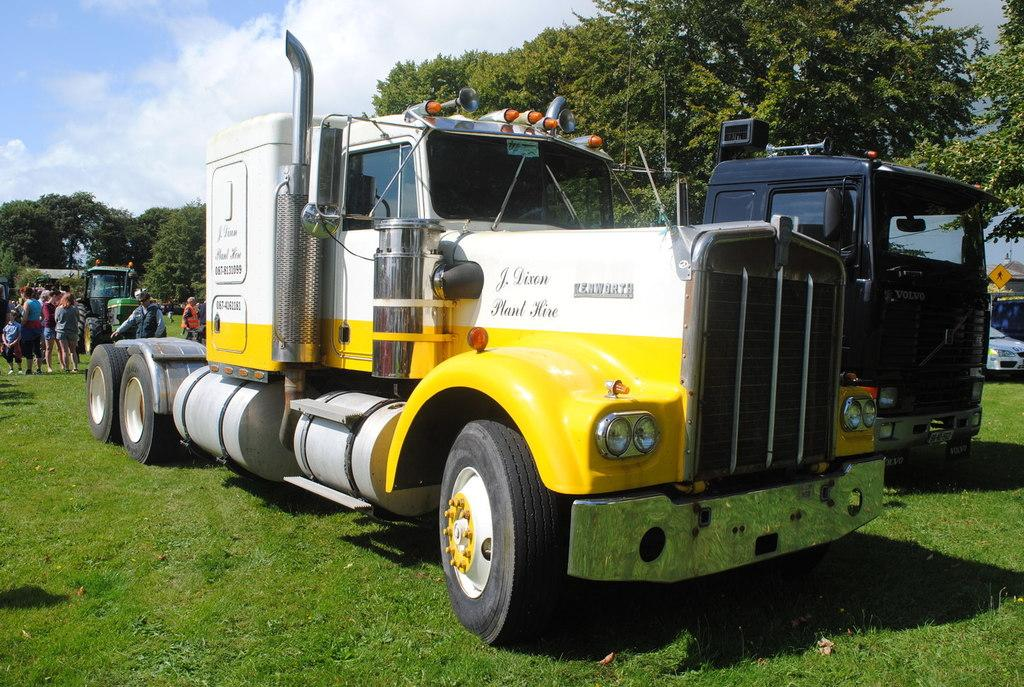What type of vehicles are on the grass in the image? There are trucks on the grass in the image. What can be seen behind the trucks? There are people standing behind the trucks. What is visible in the background of the image? There are trees in the background of the image. What type of wool is being sorted by the people in the image? There is no wool or sorting activity present in the image. What meal are the people eating while standing behind the trucks? There is no meal or eating activity present in the image. 